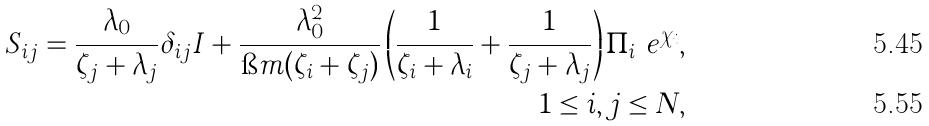<formula> <loc_0><loc_0><loc_500><loc_500>S _ { i j } = \frac { \lambda _ { 0 } } { \zeta _ { j } + \lambda _ { j } } \delta _ { i j } I + \frac { \lambda _ { 0 } ^ { 2 } } { \i m ( \zeta _ { i } + \zeta _ { j } ) } \left ( \frac { 1 } { \zeta _ { i } + \lambda _ { i } } + \frac { 1 } { \zeta _ { j } + \lambda _ { j } } \right ) \Pi _ { i } \ e ^ { \chi _ { i } } , & \\ 1 \leq i , j \leq N , &</formula> 